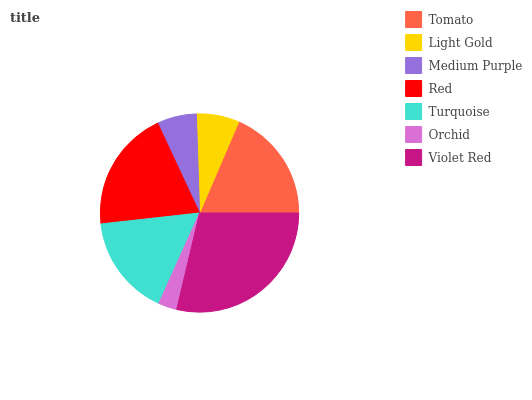Is Orchid the minimum?
Answer yes or no. Yes. Is Violet Red the maximum?
Answer yes or no. Yes. Is Light Gold the minimum?
Answer yes or no. No. Is Light Gold the maximum?
Answer yes or no. No. Is Tomato greater than Light Gold?
Answer yes or no. Yes. Is Light Gold less than Tomato?
Answer yes or no. Yes. Is Light Gold greater than Tomato?
Answer yes or no. No. Is Tomato less than Light Gold?
Answer yes or no. No. Is Turquoise the high median?
Answer yes or no. Yes. Is Turquoise the low median?
Answer yes or no. Yes. Is Violet Red the high median?
Answer yes or no. No. Is Tomato the low median?
Answer yes or no. No. 